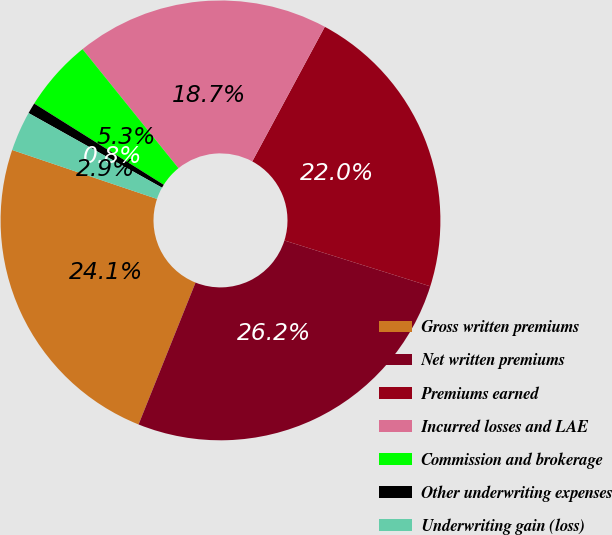Convert chart to OTSL. <chart><loc_0><loc_0><loc_500><loc_500><pie_chart><fcel>Gross written premiums<fcel>Net written premiums<fcel>Premiums earned<fcel>Incurred losses and LAE<fcel>Commission and brokerage<fcel>Other underwriting expenses<fcel>Underwriting gain (loss)<nl><fcel>24.11%<fcel>26.23%<fcel>21.98%<fcel>18.66%<fcel>5.29%<fcel>0.8%<fcel>2.93%<nl></chart> 